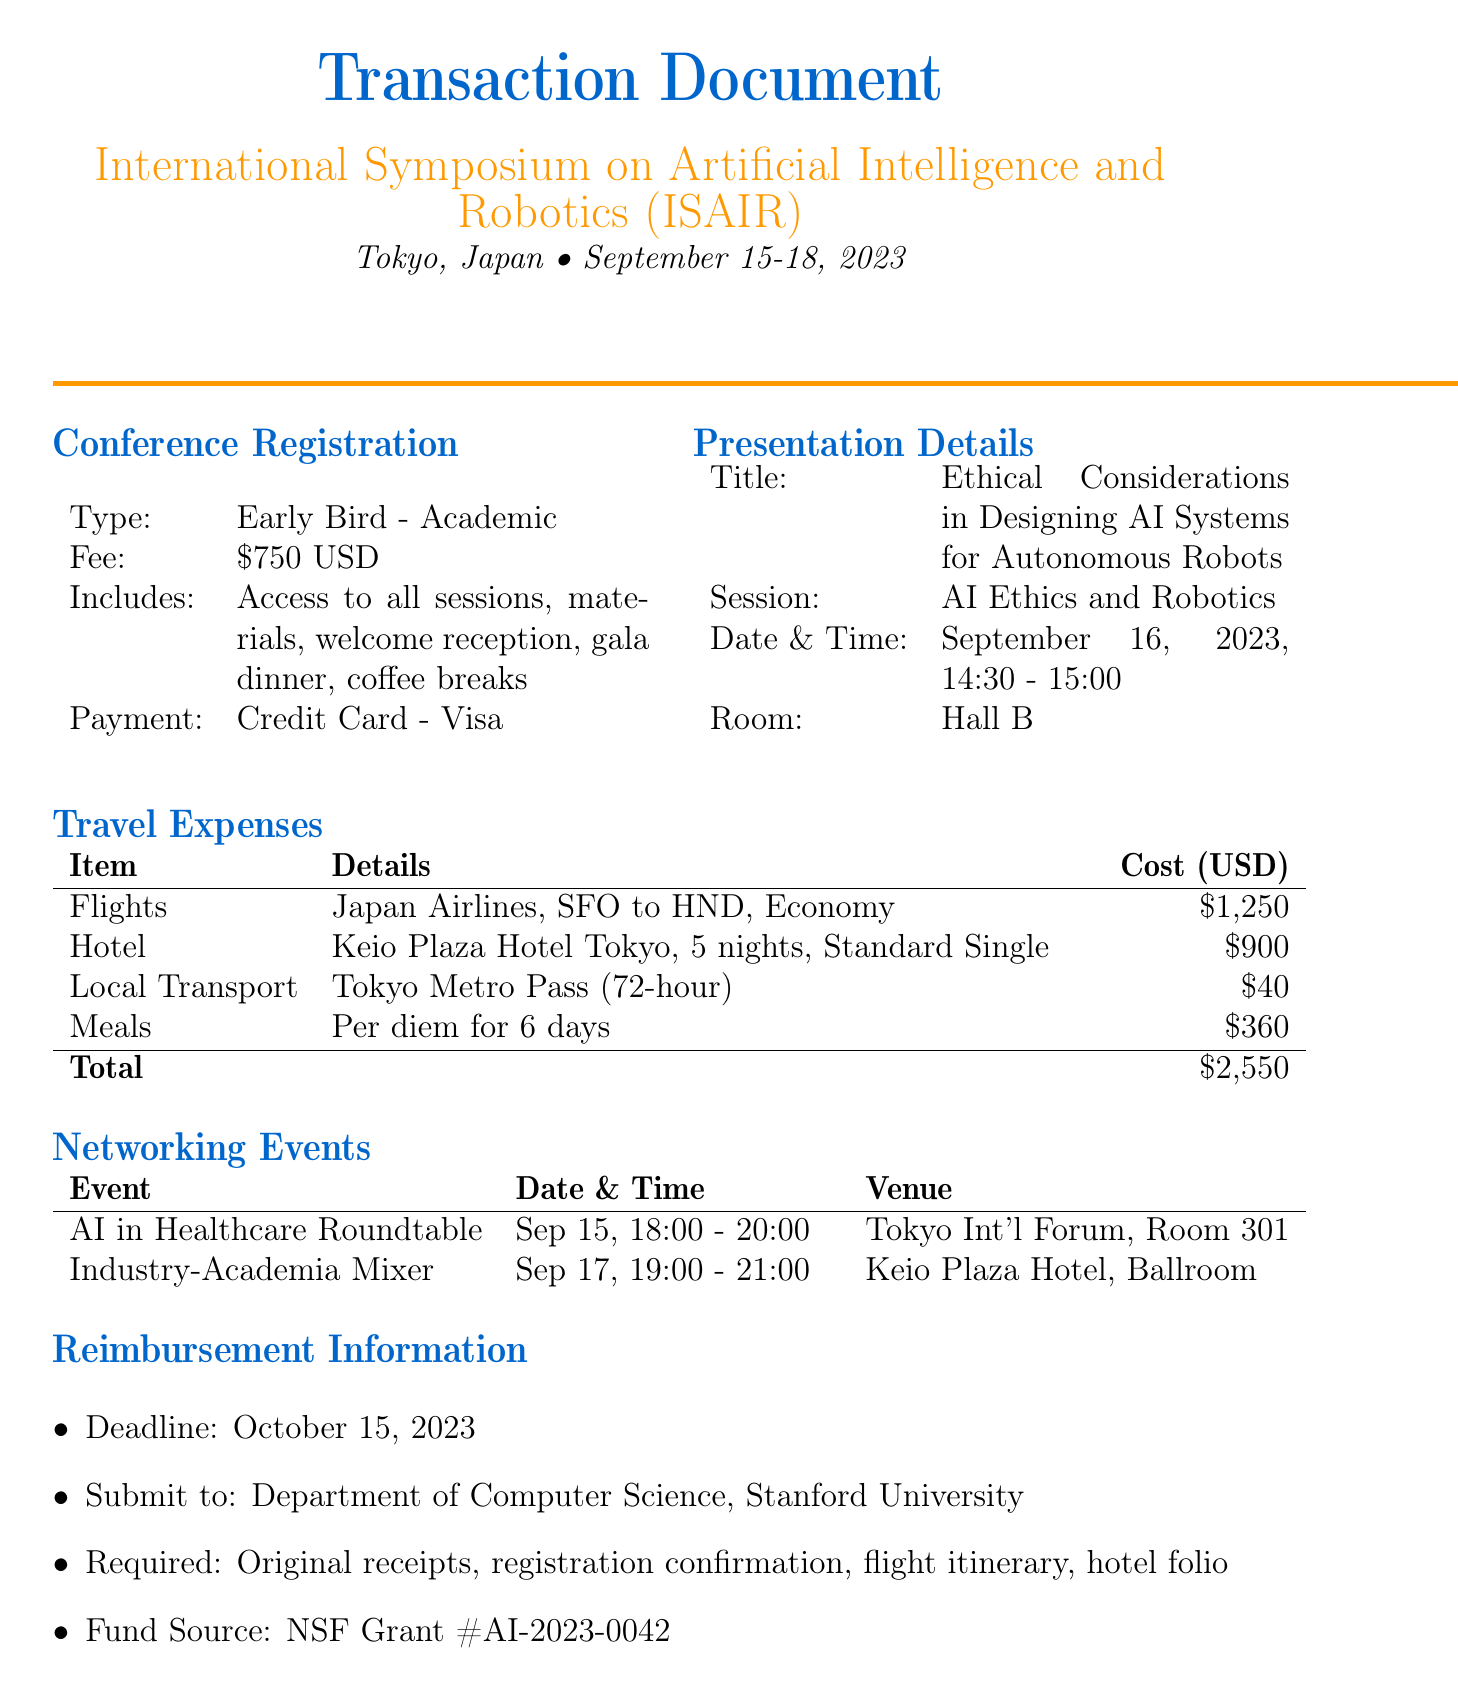what is the name of the conference? The name of the conference is provided in the document as the International Symposium on Artificial Intelligence and Robotics.
Answer: International Symposium on Artificial Intelligence and Robotics where is the symposium located? The location of the symposium is mentioned in the conference details section as Tokyo, Japan.
Answer: Tokyo, Japan how much is the registration fee? The document states the registration fee as 750 USD for the Early Bird - Academic registration type.
Answer: 750 USD what is the total cost of travel expenses? The total cost for travel expenses is indicated in the document as the sum of flights, hotel, local transport, and meals.
Answer: 2550 USD what is the date of the presentation? The date for the presentation is mentioned in the presentation details section, which is September 16, 2023.
Answer: September 16, 2023 what is the deadline for reimbursement submission? The reimbursement information section lists the deadline as October 15, 2023.
Answer: October 15, 2023 what type of hotel room was booked? The accommodation section specifies the room type, which is Standard Single at the Keio Plaza Hotel Tokyo.
Answer: Standard Single how many days is per diem calculated for meals? The meals section of the document indicates that per diem is calculated for 6 days.
Answer: 6 days what is the fund source for reimbursement? The document provides the fund source as NSF Grant #AI-2023-0042 in the reimbursement information.
Answer: NSF Grant #AI-2023-0042 